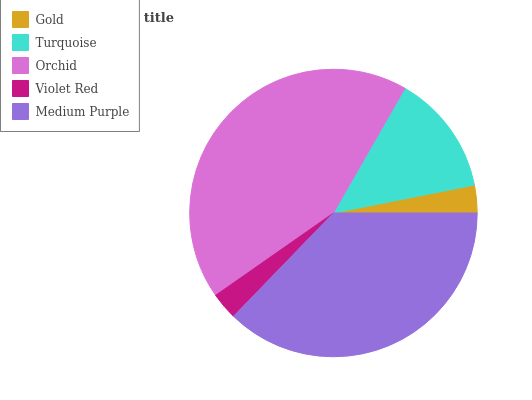Is Violet Red the minimum?
Answer yes or no. Yes. Is Orchid the maximum?
Answer yes or no. Yes. Is Turquoise the minimum?
Answer yes or no. No. Is Turquoise the maximum?
Answer yes or no. No. Is Turquoise greater than Gold?
Answer yes or no. Yes. Is Gold less than Turquoise?
Answer yes or no. Yes. Is Gold greater than Turquoise?
Answer yes or no. No. Is Turquoise less than Gold?
Answer yes or no. No. Is Turquoise the high median?
Answer yes or no. Yes. Is Turquoise the low median?
Answer yes or no. Yes. Is Violet Red the high median?
Answer yes or no. No. Is Gold the low median?
Answer yes or no. No. 